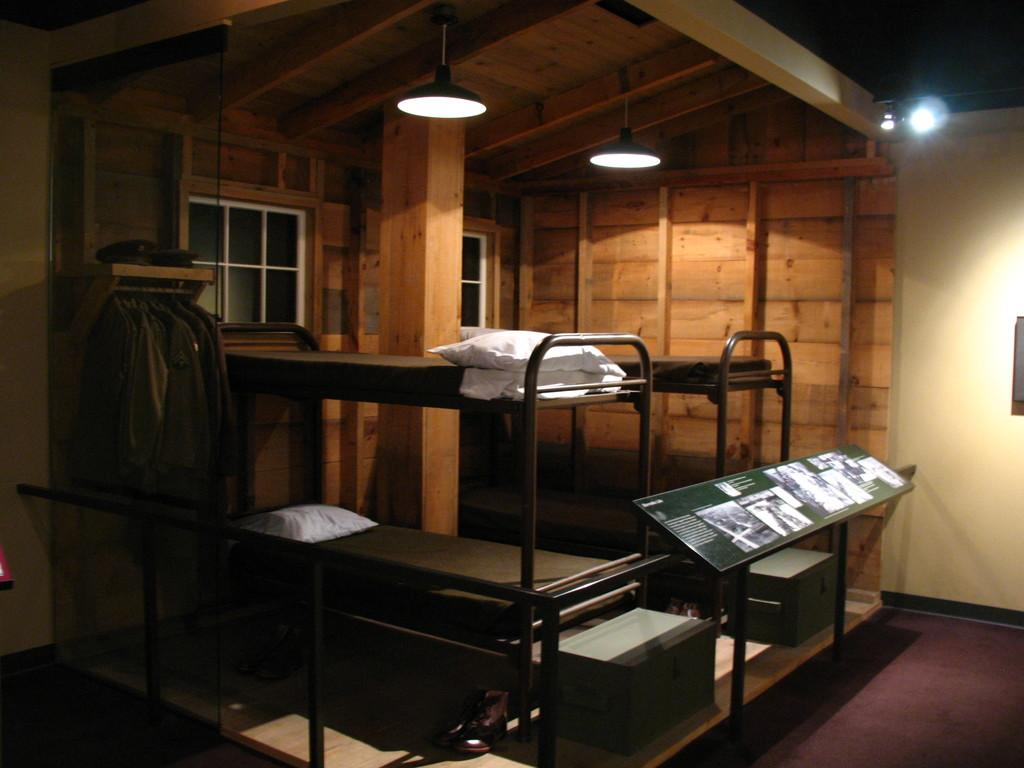What type of entryway is visible in the image? There is a door in the image. What can be used for ventilation or viewing the outside in the image? There are windows in the image. What type of fabric items are present in the image? There are cloths in the image. What can provide illumination in the image? There are lights in the image. What type of furniture is present for sleeping in the image? There are beds in the image. What type of decoration is present in the image? There is a banner in the image. What type of pillows are present in the image? There are white color pillows in the image. Where is the zipper located on the banner in the image? There is no zipper present on the banner in the image. How does the image show respect for the environment? The image does not show any specific actions or items related to respecting the environment. 